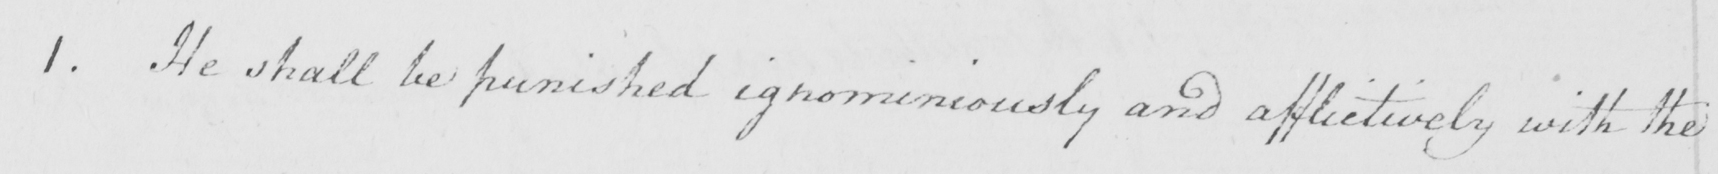Transcribe the text shown in this historical manuscript line. 1 . He shall be punished ignominiously and afflictively with the 